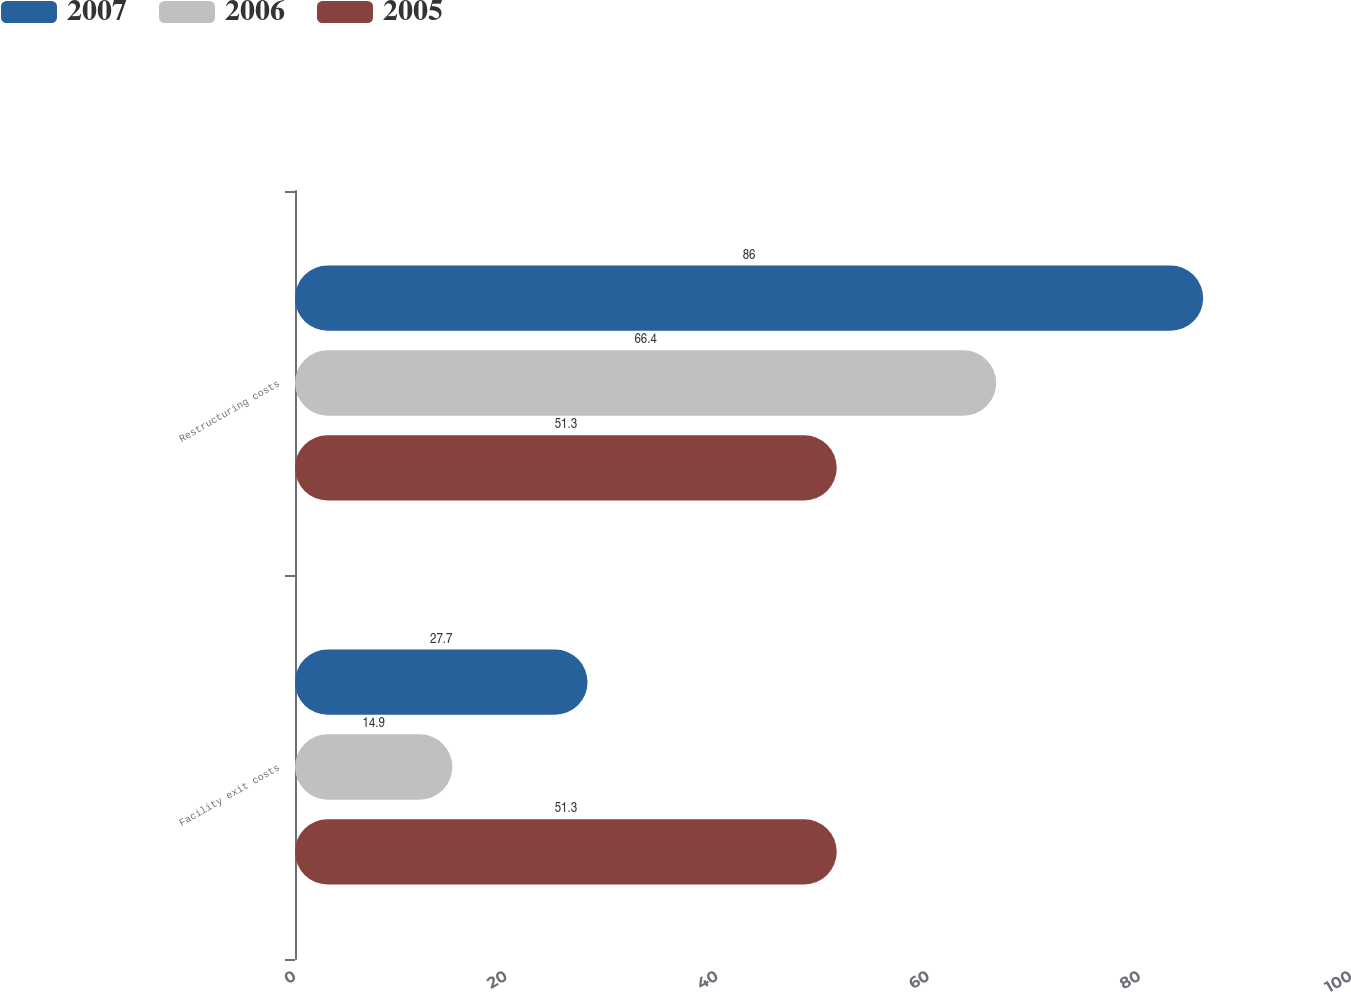Convert chart to OTSL. <chart><loc_0><loc_0><loc_500><loc_500><stacked_bar_chart><ecel><fcel>Facility exit costs<fcel>Restructuring costs<nl><fcel>2007<fcel>27.7<fcel>86<nl><fcel>2006<fcel>14.9<fcel>66.4<nl><fcel>2005<fcel>51.3<fcel>51.3<nl></chart> 